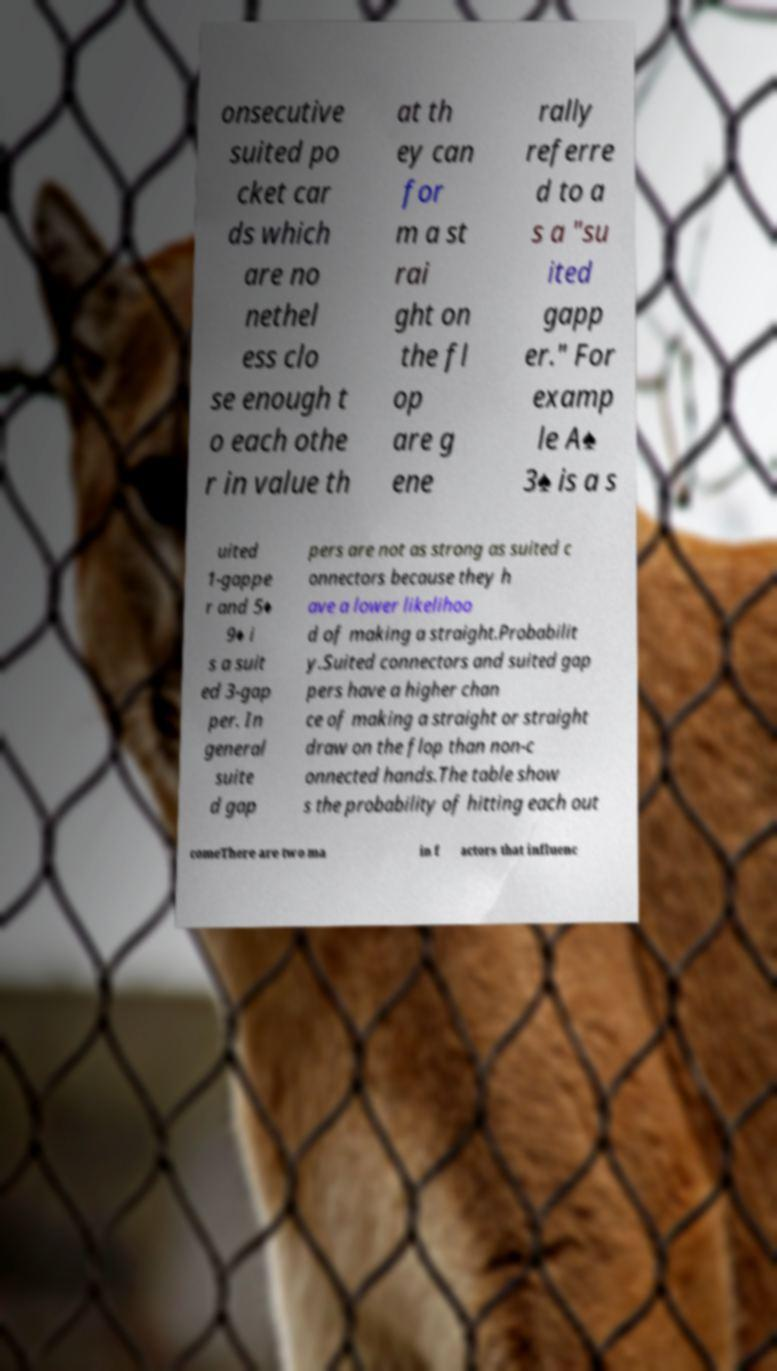Can you read and provide the text displayed in the image?This photo seems to have some interesting text. Can you extract and type it out for me? onsecutive suited po cket car ds which are no nethel ess clo se enough t o each othe r in value th at th ey can for m a st rai ght on the fl op are g ene rally referre d to a s a "su ited gapp er." For examp le A♠ 3♠ is a s uited 1-gappe r and 5♦ 9♦ i s a suit ed 3-gap per. In general suite d gap pers are not as strong as suited c onnectors because they h ave a lower likelihoo d of making a straight.Probabilit y.Suited connectors and suited gap pers have a higher chan ce of making a straight or straight draw on the flop than non-c onnected hands.The table show s the probability of hitting each out comeThere are two ma in f actors that influenc 